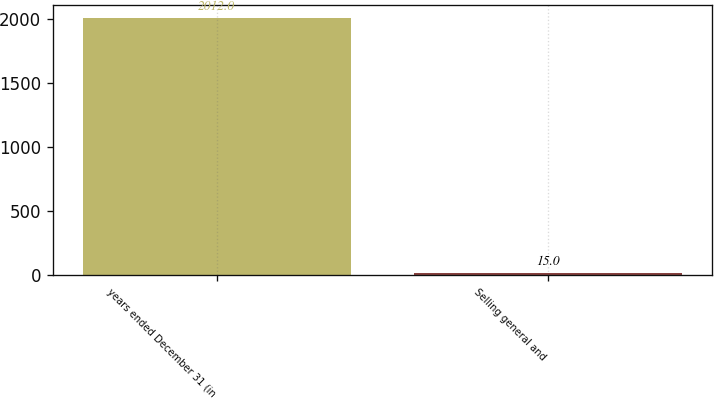Convert chart to OTSL. <chart><loc_0><loc_0><loc_500><loc_500><bar_chart><fcel>years ended December 31 (in<fcel>Selling general and<nl><fcel>2012<fcel>15<nl></chart> 